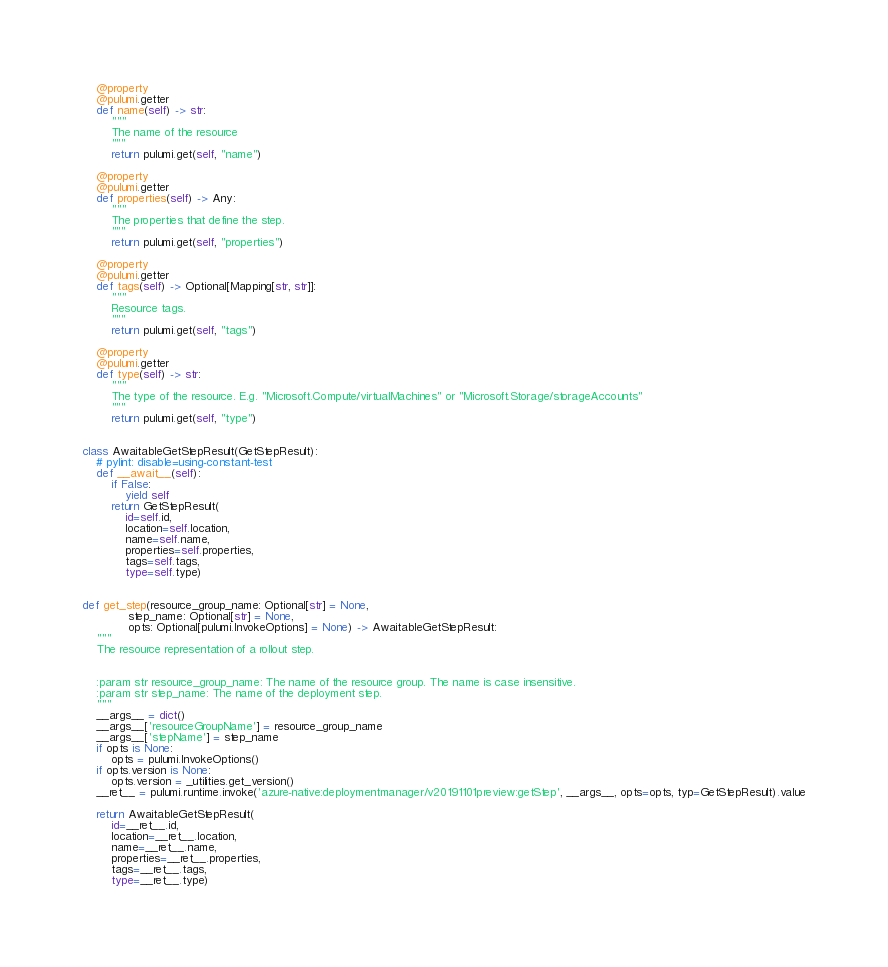Convert code to text. <code><loc_0><loc_0><loc_500><loc_500><_Python_>    @property
    @pulumi.getter
    def name(self) -> str:
        """
        The name of the resource
        """
        return pulumi.get(self, "name")

    @property
    @pulumi.getter
    def properties(self) -> Any:
        """
        The properties that define the step.
        """
        return pulumi.get(self, "properties")

    @property
    @pulumi.getter
    def tags(self) -> Optional[Mapping[str, str]]:
        """
        Resource tags.
        """
        return pulumi.get(self, "tags")

    @property
    @pulumi.getter
    def type(self) -> str:
        """
        The type of the resource. E.g. "Microsoft.Compute/virtualMachines" or "Microsoft.Storage/storageAccounts"
        """
        return pulumi.get(self, "type")


class AwaitableGetStepResult(GetStepResult):
    # pylint: disable=using-constant-test
    def __await__(self):
        if False:
            yield self
        return GetStepResult(
            id=self.id,
            location=self.location,
            name=self.name,
            properties=self.properties,
            tags=self.tags,
            type=self.type)


def get_step(resource_group_name: Optional[str] = None,
             step_name: Optional[str] = None,
             opts: Optional[pulumi.InvokeOptions] = None) -> AwaitableGetStepResult:
    """
    The resource representation of a rollout step.


    :param str resource_group_name: The name of the resource group. The name is case insensitive.
    :param str step_name: The name of the deployment step.
    """
    __args__ = dict()
    __args__['resourceGroupName'] = resource_group_name
    __args__['stepName'] = step_name
    if opts is None:
        opts = pulumi.InvokeOptions()
    if opts.version is None:
        opts.version = _utilities.get_version()
    __ret__ = pulumi.runtime.invoke('azure-native:deploymentmanager/v20191101preview:getStep', __args__, opts=opts, typ=GetStepResult).value

    return AwaitableGetStepResult(
        id=__ret__.id,
        location=__ret__.location,
        name=__ret__.name,
        properties=__ret__.properties,
        tags=__ret__.tags,
        type=__ret__.type)
</code> 